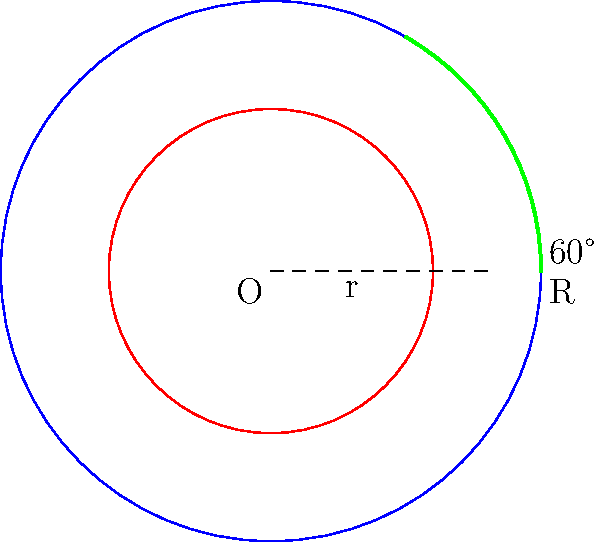A thrust bearing's cage has an outer radius (R) of 150 mm and an inner radius (r) of 90 mm. If the cage rotates through an angle of 60°, calculate:

a) The circumference of the cage's centerline
b) The arc length of the cage's centerline for the given rotation

Round your answers to the nearest millimeter. Let's approach this step-by-step:

1) First, we need to find the radius of the cage's centerline. The centerline is halfway between the inner and outer radii:

   Centerline radius = $\frac{R + r}{2} = \frac{150 + 90}{2} = 120$ mm

2) To calculate the circumference of the centerline:
   
   Circumference = $2\pi r$
   
   Where r is the centerline radius:
   
   Circumference = $2\pi(120) \approx 753.98$ mm

3) To calculate the arc length for a 60° rotation:
   
   Arc length = $\frac{\theta}{360°} \cdot 2\pi r$
   
   Where $\theta$ is the angle in degrees and r is the centerline radius:
   
   Arc length = $\frac{60}{360} \cdot 2\pi(120) \approx 125.66$ mm

4) Rounding to the nearest millimeter:
   
   Circumference ≈ 754 mm
   Arc length ≈ 126 mm
Answer: a) 754 mm
b) 126 mm 